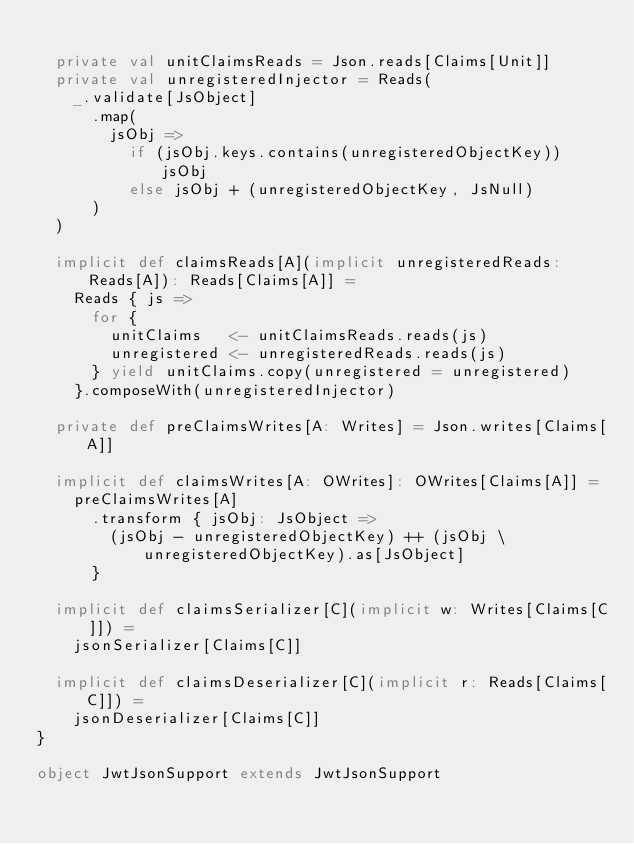<code> <loc_0><loc_0><loc_500><loc_500><_Scala_>
  private val unitClaimsReads = Json.reads[Claims[Unit]]
  private val unregisteredInjector = Reads(
    _.validate[JsObject]
      .map(
        jsObj =>
          if (jsObj.keys.contains(unregisteredObjectKey)) jsObj
          else jsObj + (unregisteredObjectKey, JsNull)
      )
  )

  implicit def claimsReads[A](implicit unregisteredReads: Reads[A]): Reads[Claims[A]] =
    Reads { js =>
      for {
        unitClaims   <- unitClaimsReads.reads(js)
        unregistered <- unregisteredReads.reads(js)
      } yield unitClaims.copy(unregistered = unregistered)
    }.composeWith(unregisteredInjector)

  private def preClaimsWrites[A: Writes] = Json.writes[Claims[A]]

  implicit def claimsWrites[A: OWrites]: OWrites[Claims[A]] =
    preClaimsWrites[A]
      .transform { jsObj: JsObject =>
        (jsObj - unregisteredObjectKey) ++ (jsObj \ unregisteredObjectKey).as[JsObject]
      }

  implicit def claimsSerializer[C](implicit w: Writes[Claims[C]]) =
    jsonSerializer[Claims[C]]

  implicit def claimsDeserializer[C](implicit r: Reads[Claims[C]]) =
    jsonDeserializer[Claims[C]]
}

object JwtJsonSupport extends JwtJsonSupport
</code> 